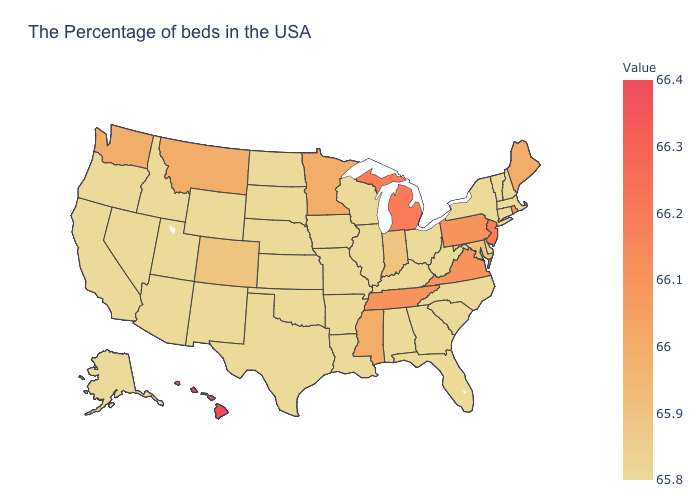Among the states that border Michigan , does Wisconsin have the highest value?
Quick response, please. No. Which states have the lowest value in the USA?
Give a very brief answer. Massachusetts, New Hampshire, Vermont, Connecticut, New York, Delaware, North Carolina, South Carolina, West Virginia, Ohio, Florida, Georgia, Kentucky, Alabama, Wisconsin, Illinois, Louisiana, Missouri, Arkansas, Iowa, Kansas, Nebraska, Oklahoma, Texas, South Dakota, North Dakota, Wyoming, New Mexico, Utah, Arizona, Idaho, Nevada, California, Oregon, Alaska. Which states hav the highest value in the West?
Answer briefly. Hawaii. Does Oregon have a lower value than Colorado?
Give a very brief answer. Yes. 